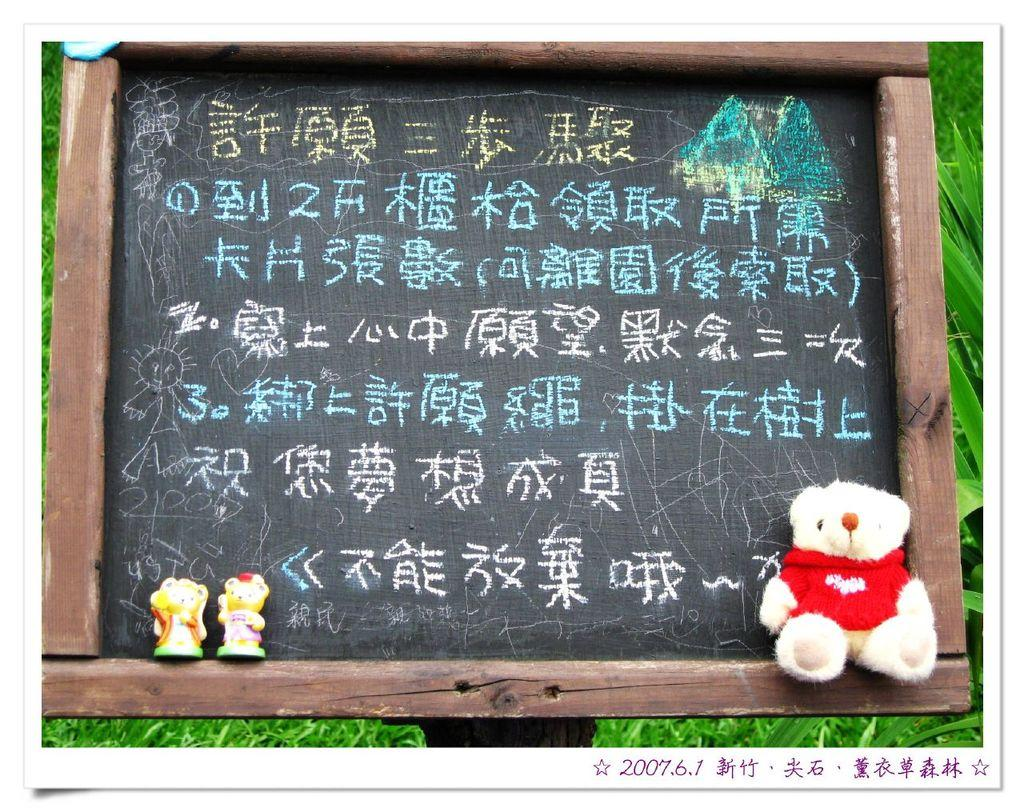What is the main object in the image? There is a blackboard in the image. What is written or drawn on the blackboard? There is text on the blackboard. Are there any additional objects on the blackboard? Yes, there is a teddy bear and two toys on the blackboard. What can be seen in the background of the image? There are plants in the background of the image. Can you see the ocean in the background of the image? No, there is no ocean visible in the image. The background features plants, not an ocean. 